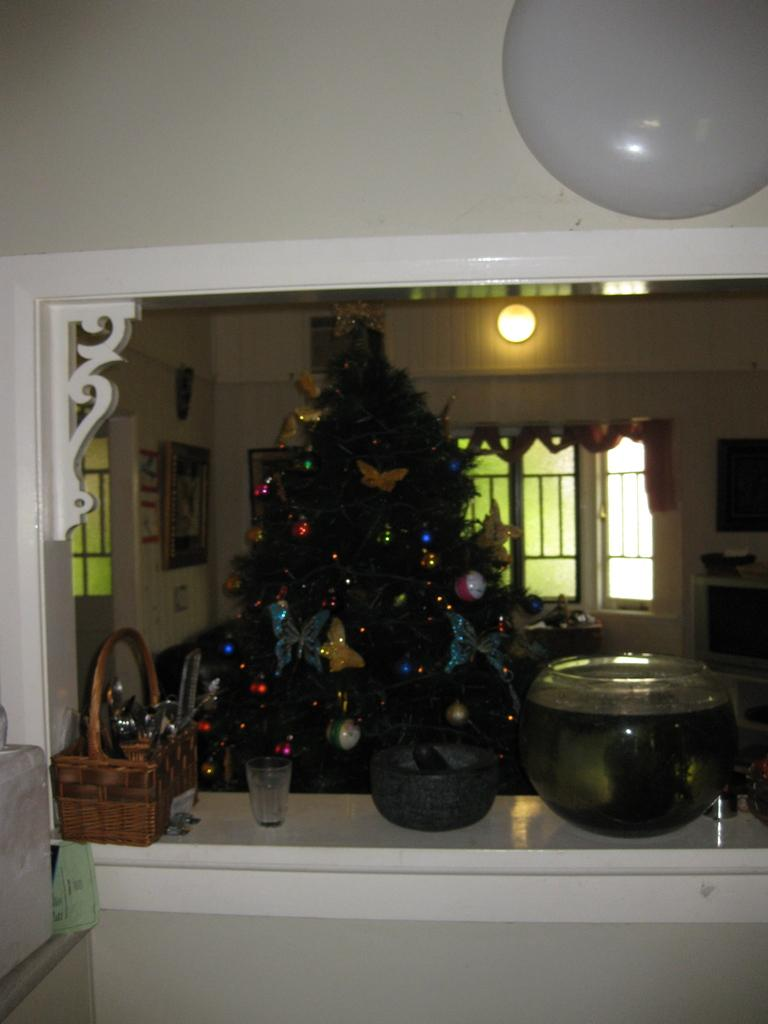What type of tree is in the image? There is a Christmas tree in the image. What can be seen on or around the tree? Decorative items are present in the image. What is the container used for in the image? The container's purpose is not specified, but it is visible in the image. What material is the glass object made of? The glass object is made of glass, as indicated by the fact that it is described as a "glass object." What is the wooden basket used for in the image? The purpose of the wooden basket is not specified, but it is visible in the image. What type of light is present in the image? There is light in the image, but the specific type of light is not mentioned. What can be seen through the window in the image? The view through the window is not described in the facts provided. What is the wall made of in the image? The material of the wall is not specified in the facts provided. What type of collar is the animal wearing in the image? There is no animal present in the image, so there is no collar to be seen. 